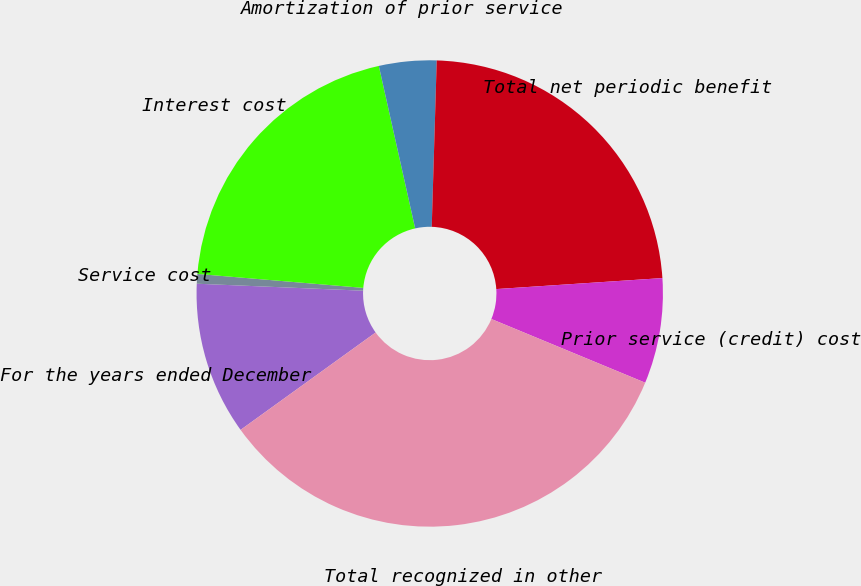<chart> <loc_0><loc_0><loc_500><loc_500><pie_chart><fcel>For the years ended December<fcel>Service cost<fcel>Interest cost<fcel>Amortization of prior service<fcel>Total net periodic benefit<fcel>Prior service (credit) cost<fcel>Total recognized in other<nl><fcel>10.61%<fcel>0.67%<fcel>20.16%<fcel>3.98%<fcel>23.47%<fcel>7.3%<fcel>33.81%<nl></chart> 